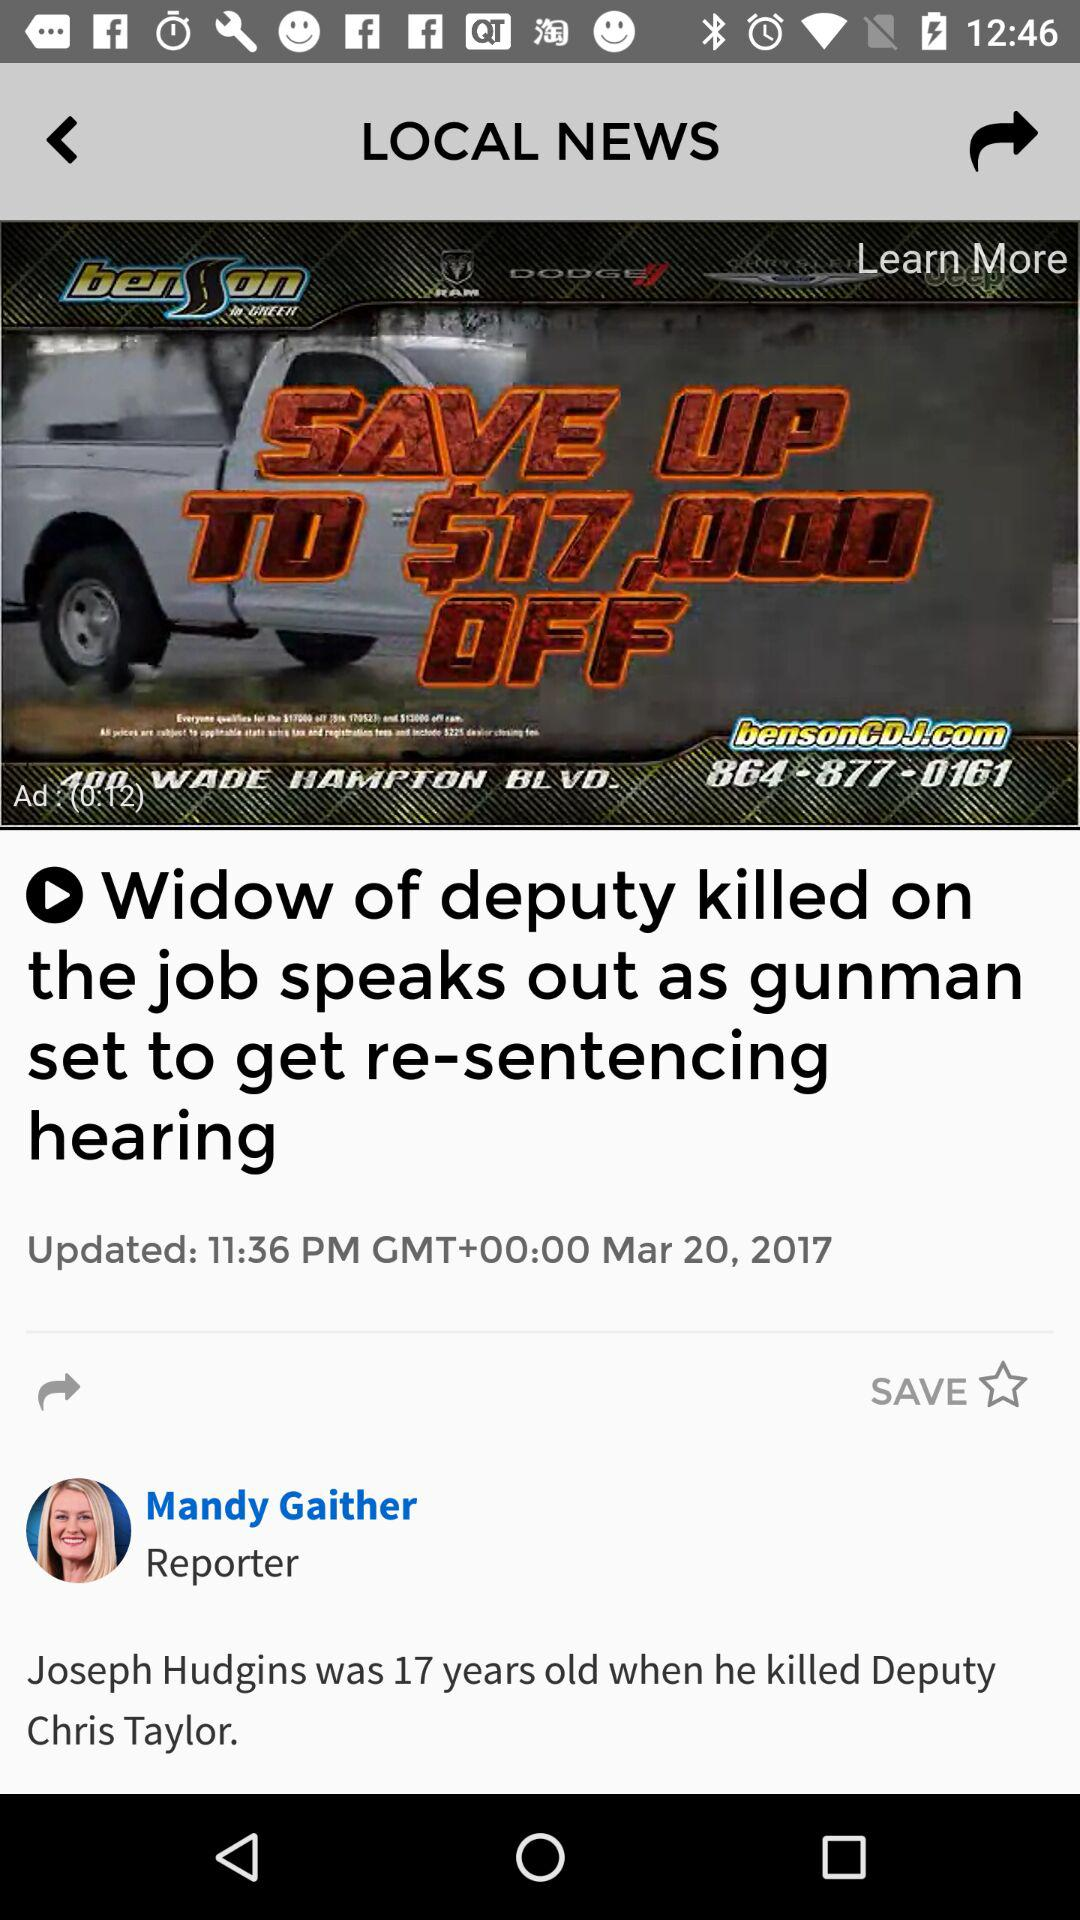What type of news is this? The type is "LOCAL NEWS". 